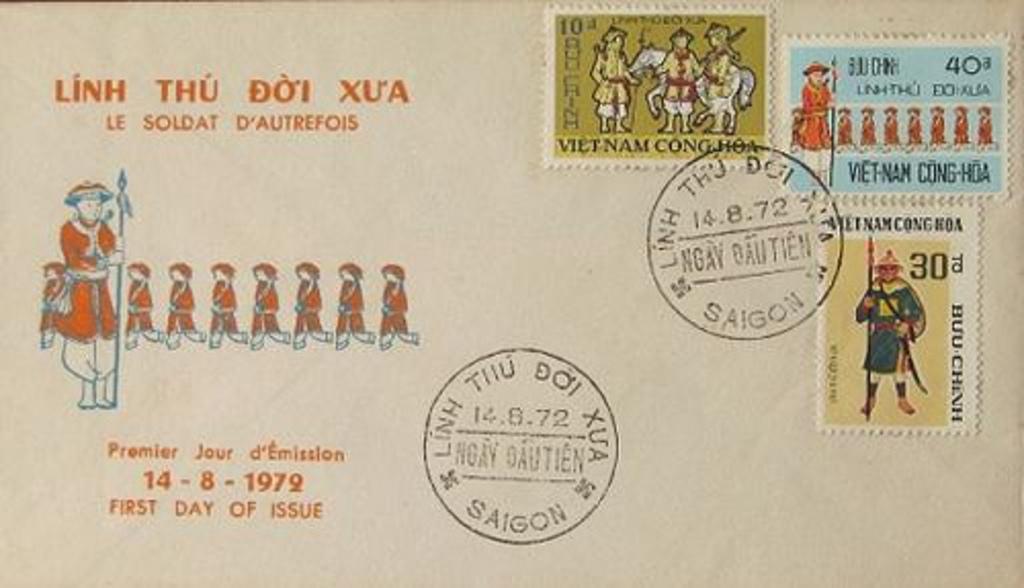How would you summarize this image in a sentence or two? This picture looks like an envelope on which I can see a group of people and persons stamp. 